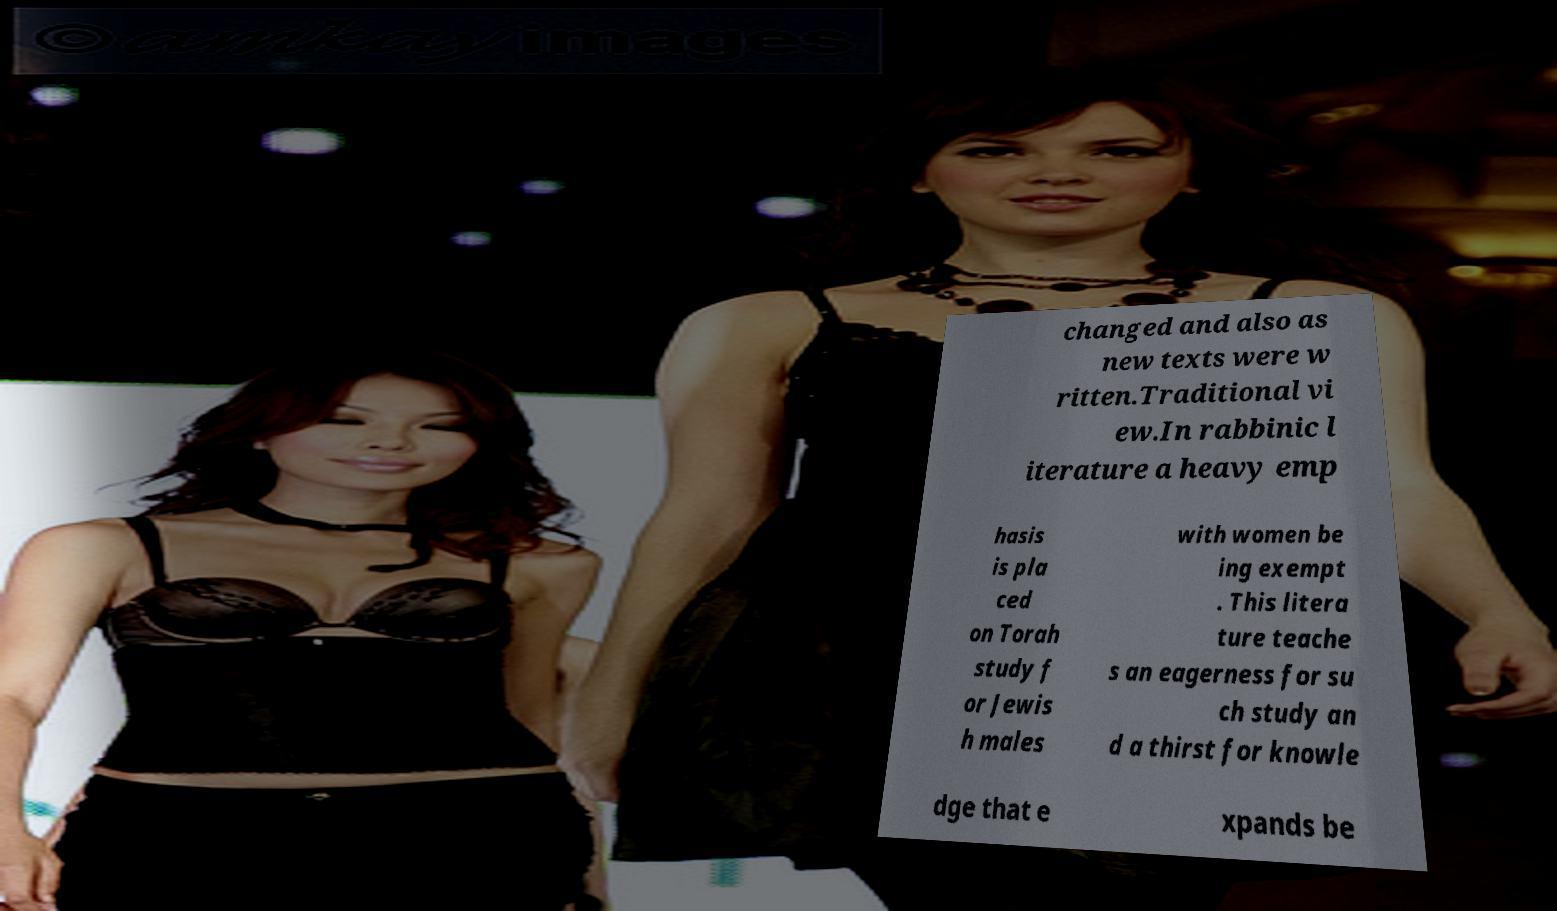Could you assist in decoding the text presented in this image and type it out clearly? changed and also as new texts were w ritten.Traditional vi ew.In rabbinic l iterature a heavy emp hasis is pla ced on Torah study f or Jewis h males with women be ing exempt . This litera ture teache s an eagerness for su ch study an d a thirst for knowle dge that e xpands be 